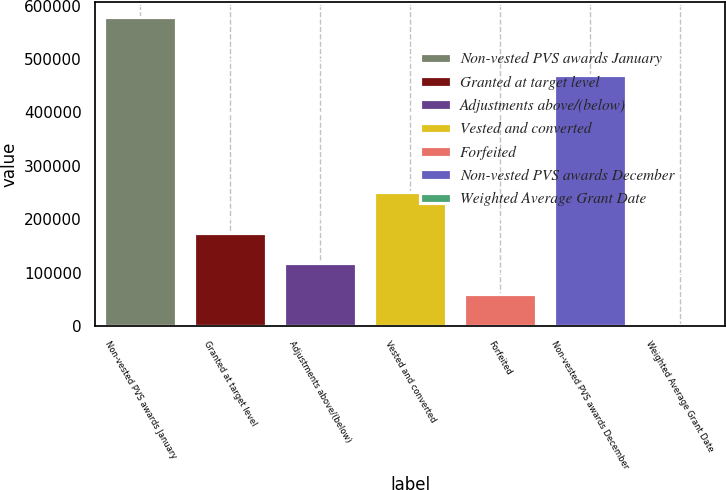<chart> <loc_0><loc_0><loc_500><loc_500><bar_chart><fcel>Non-vested PVS awards January<fcel>Granted at target level<fcel>Adjustments above/(below)<fcel>Vested and converted<fcel>Forfeited<fcel>Non-vested PVS awards December<fcel>Weighted Average Grant Date<nl><fcel>578358<fcel>174917<fcel>117283<fcel>250205<fcel>59648.4<fcel>470719<fcel>2014<nl></chart> 